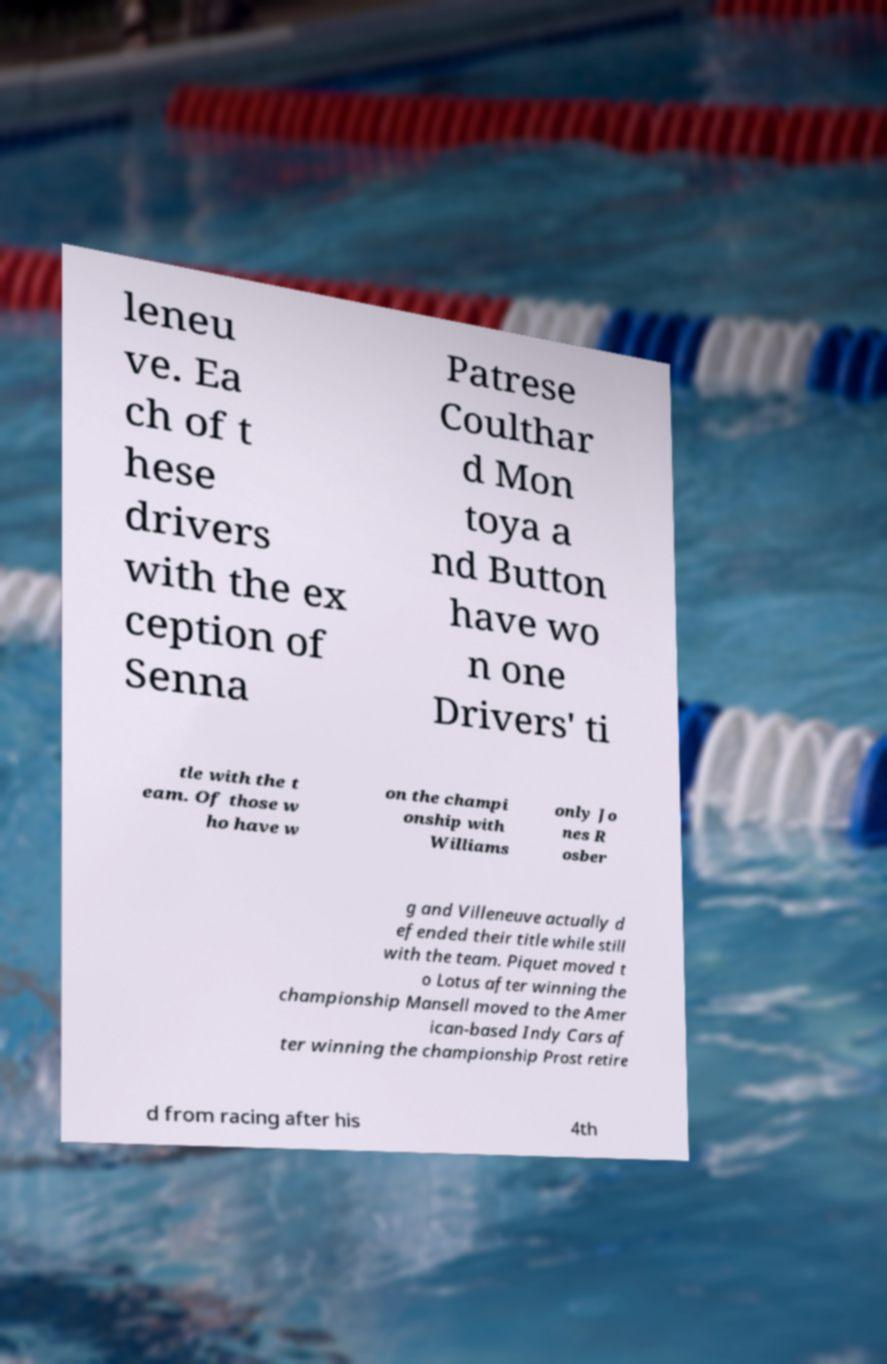Please identify and transcribe the text found in this image. leneu ve. Ea ch of t hese drivers with the ex ception of Senna Patrese Coulthar d Mon toya a nd Button have wo n one Drivers' ti tle with the t eam. Of those w ho have w on the champi onship with Williams only Jo nes R osber g and Villeneuve actually d efended their title while still with the team. Piquet moved t o Lotus after winning the championship Mansell moved to the Amer ican-based Indy Cars af ter winning the championship Prost retire d from racing after his 4th 